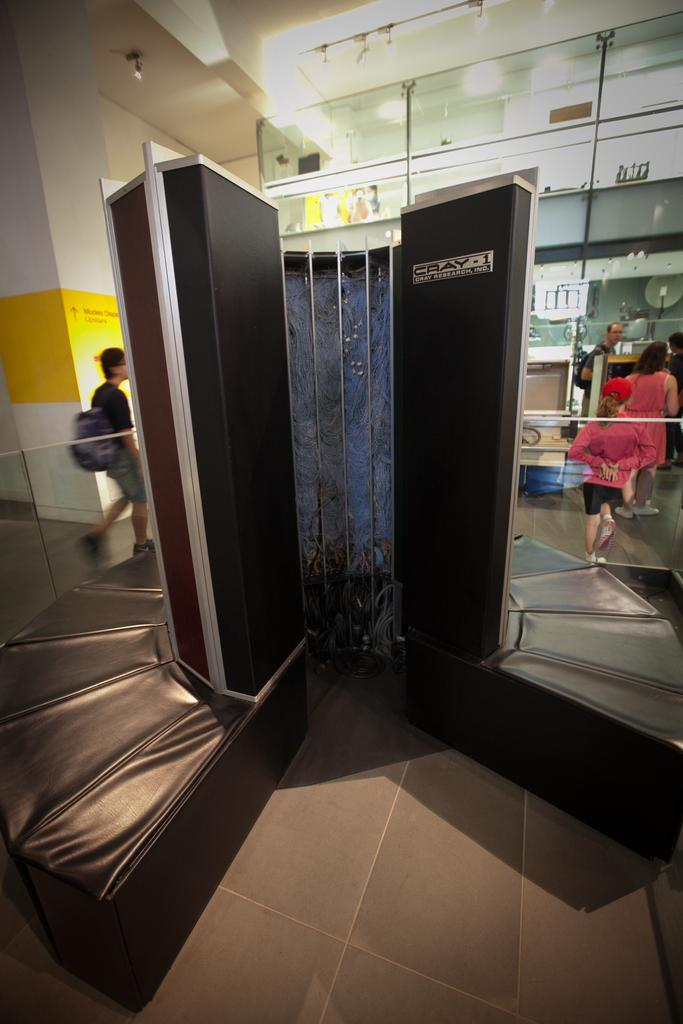What type of furniture is depicted in the image? The image appears to show a cupboard-cum-sofa. Can you describe the people in the image? There are people in the image, but their specific actions or appearances are not mentioned in the provided facts. What objects can be seen in the background of the image? There are glasses and lights in the background of the image. What message of peace is being conveyed by the head of the person in the image? There is no mention of a message of peace or a person's head in the provided facts, so we cannot answer this question. How does the image express feelings of hate? The image does not express feelings of hate, as there is no indication of such emotions in the provided facts. 